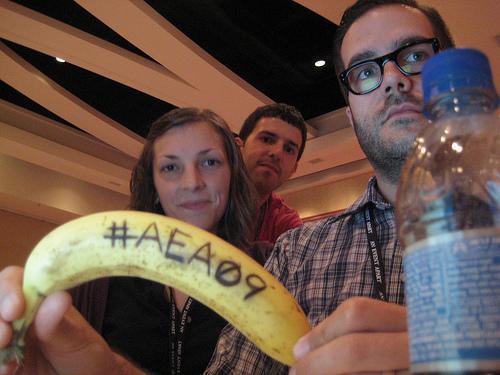How many people are in the room?
Give a very brief answer. 3. 